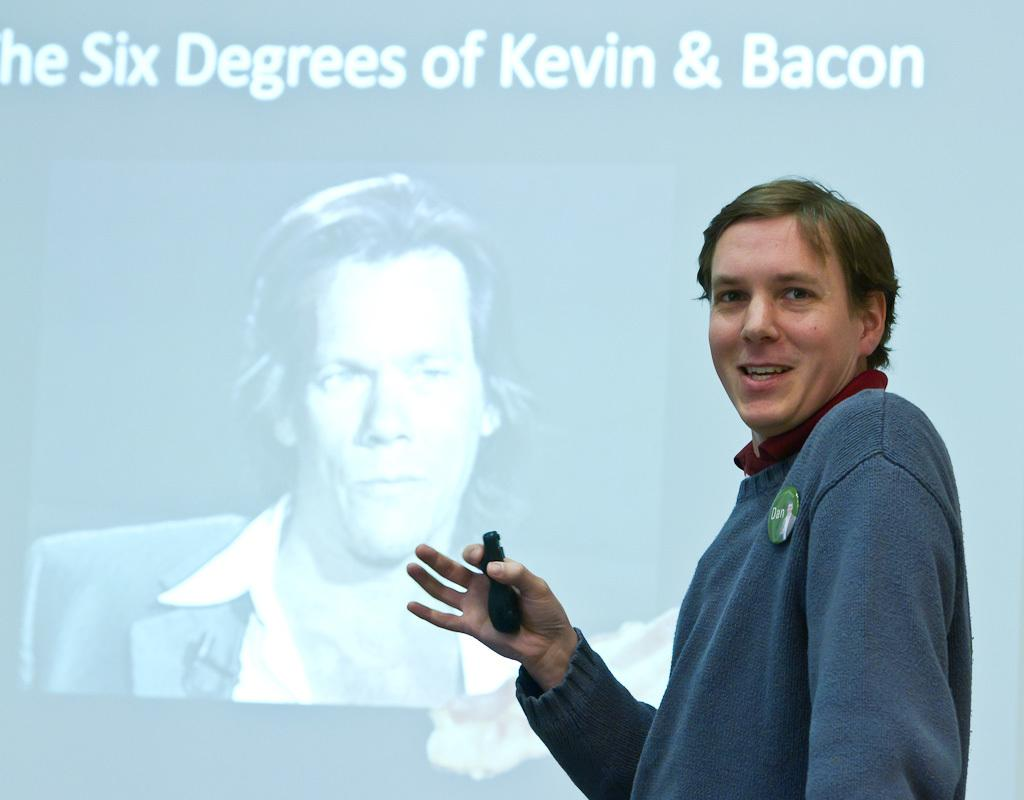What is the man in the image doing? The man is giving a seminar. How does the man appear in the image? The man is smiling in the image. What is present in the image that might be used for displaying information? There is a screen in the image. What is shown on the screen in the image? The screen displays an image related to "six degrees of Kevin Bacon." What type of vacation is being advertised on the screen in the image? There is no advertisement or vacation mentioned in the image; the screen displays an image related to "six degrees of Kevin Bacon." What scent can be detected in the room where the seminar is taking place? There is no information about the scent in the room where the seminar is taking place. 